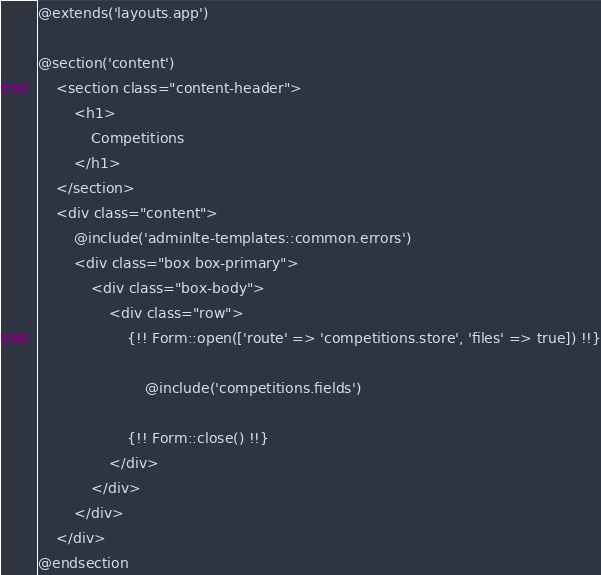<code> <loc_0><loc_0><loc_500><loc_500><_PHP_>@extends('layouts.app')

@section('content')
    <section class="content-header">
        <h1>
            Competitions
        </h1>
    </section>
    <div class="content">
        @include('adminlte-templates::common.errors')
        <div class="box box-primary">
            <div class="box-body">
                <div class="row">
                    {!! Form::open(['route' => 'competitions.store', 'files' => true]) !!}

                        @include('competitions.fields')

                    {!! Form::close() !!}
                </div>
            </div>
        </div>
    </div>
@endsection
</code> 